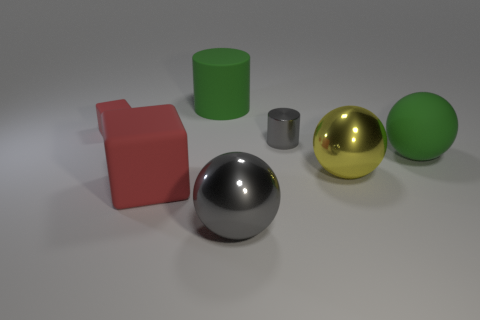Add 1 tiny gray metallic things. How many objects exist? 8 Subtract all matte spheres. How many spheres are left? 2 Subtract 2 blocks. How many blocks are left? 0 Subtract all yellow spheres. How many spheres are left? 2 Subtract all spheres. How many objects are left? 4 Subtract all red matte cubes. Subtract all tiny cyan metal balls. How many objects are left? 5 Add 2 green things. How many green things are left? 4 Add 7 small matte cylinders. How many small matte cylinders exist? 7 Subtract 1 red blocks. How many objects are left? 6 Subtract all cyan blocks. Subtract all gray cylinders. How many blocks are left? 2 